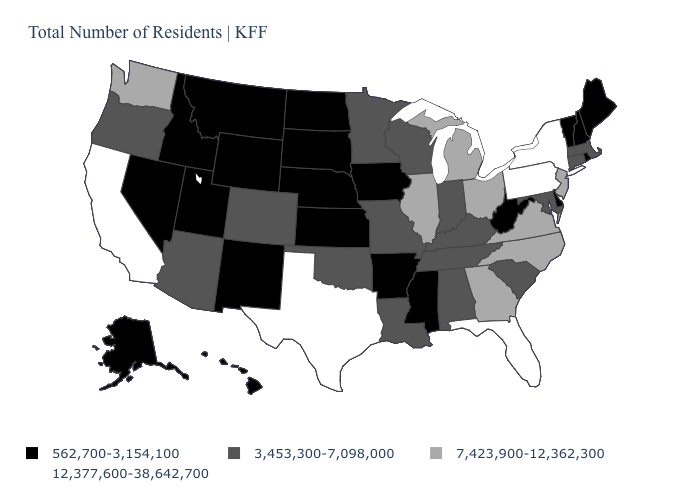What is the value of Michigan?
Quick response, please. 7,423,900-12,362,300. What is the value of Utah?
Give a very brief answer. 562,700-3,154,100. What is the value of Kansas?
Give a very brief answer. 562,700-3,154,100. What is the highest value in the USA?
Give a very brief answer. 12,377,600-38,642,700. How many symbols are there in the legend?
Concise answer only. 4. Among the states that border Oklahoma , which have the lowest value?
Short answer required. Arkansas, Kansas, New Mexico. What is the value of Hawaii?
Be succinct. 562,700-3,154,100. What is the highest value in states that border Georgia?
Keep it brief. 12,377,600-38,642,700. What is the value of South Dakota?
Give a very brief answer. 562,700-3,154,100. Does Alaska have the lowest value in the USA?
Be succinct. Yes. Does Pennsylvania have the highest value in the USA?
Keep it brief. Yes. Which states have the lowest value in the USA?
Write a very short answer. Alaska, Arkansas, Delaware, Hawaii, Idaho, Iowa, Kansas, Maine, Mississippi, Montana, Nebraska, Nevada, New Hampshire, New Mexico, North Dakota, Rhode Island, South Dakota, Utah, Vermont, West Virginia, Wyoming. What is the value of Connecticut?
Write a very short answer. 3,453,300-7,098,000. Name the states that have a value in the range 3,453,300-7,098,000?
Be succinct. Alabama, Arizona, Colorado, Connecticut, Indiana, Kentucky, Louisiana, Maryland, Massachusetts, Minnesota, Missouri, Oklahoma, Oregon, South Carolina, Tennessee, Wisconsin. Name the states that have a value in the range 12,377,600-38,642,700?
Keep it brief. California, Florida, New York, Pennsylvania, Texas. 